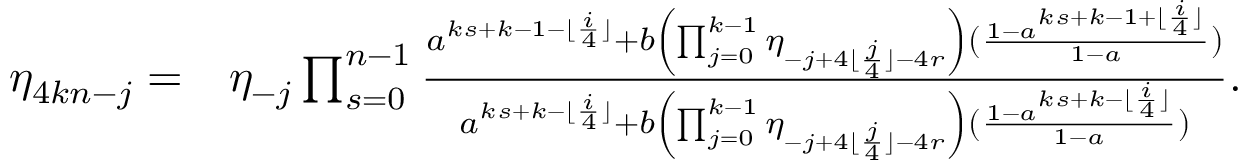Convert formula to latex. <formula><loc_0><loc_0><loc_500><loc_500>\begin{array} { r l } { \eta _ { 4 k n - j } = } & { \eta _ { - j } \prod _ { s = 0 } ^ { n - 1 } \frac { a ^ { k s + k - 1 - \lfloor \frac { i } { 4 } \rfloor } + b \left ( \prod _ { j = 0 } ^ { k - 1 } { \eta _ { - j + 4 \lfloor \frac { j } { 4 } \rfloor - 4 r } } \right ) ( \frac { 1 - a ^ { k s + k - 1 + \lfloor \frac { i } { 4 } \rfloor } } { 1 - a } ) } { a ^ { k s + k - \lfloor \frac { i } { 4 } \rfloor } + b \left ( \prod _ { j = 0 } ^ { k - 1 } { \eta _ { - j + 4 \lfloor \frac { j } { 4 } \rfloor - 4 r } } \right ) ( \frac { 1 - a ^ { k s + k - \lfloor \frac { i } { 4 } \rfloor } } { 1 - a } ) } . } \end{array}</formula> 